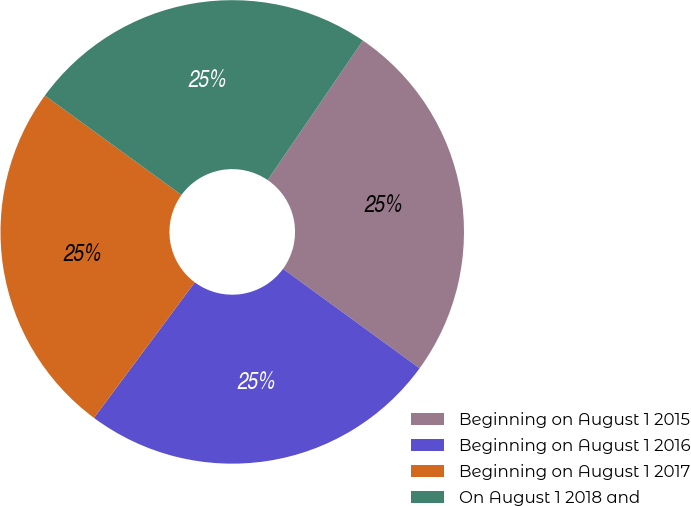Convert chart. <chart><loc_0><loc_0><loc_500><loc_500><pie_chart><fcel>Beginning on August 1 2015<fcel>Beginning on August 1 2016<fcel>Beginning on August 1 2017<fcel>On August 1 2018 and<nl><fcel>25.48%<fcel>25.16%<fcel>24.84%<fcel>24.52%<nl></chart> 